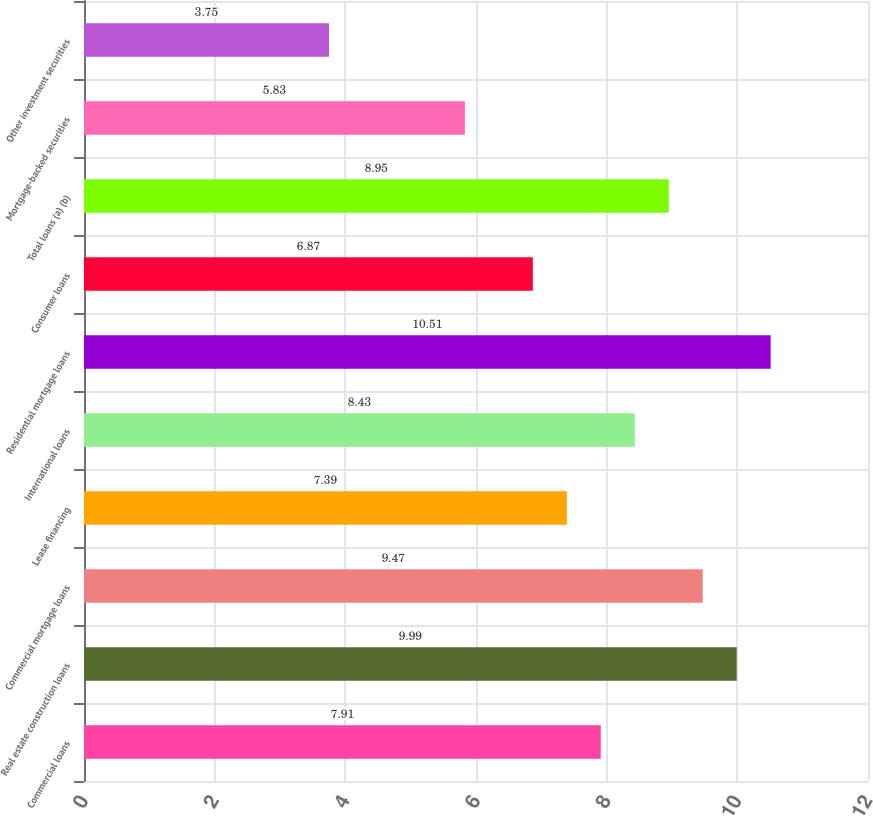Convert chart to OTSL. <chart><loc_0><loc_0><loc_500><loc_500><bar_chart><fcel>Commercial loans<fcel>Real estate construction loans<fcel>Commercial mortgage loans<fcel>Lease financing<fcel>International loans<fcel>Residential mortgage loans<fcel>Consumer loans<fcel>Total loans (a) (b)<fcel>Mortgage-backed securities<fcel>Other investment securities<nl><fcel>7.91<fcel>9.99<fcel>9.47<fcel>7.39<fcel>8.43<fcel>10.51<fcel>6.87<fcel>8.95<fcel>5.83<fcel>3.75<nl></chart> 